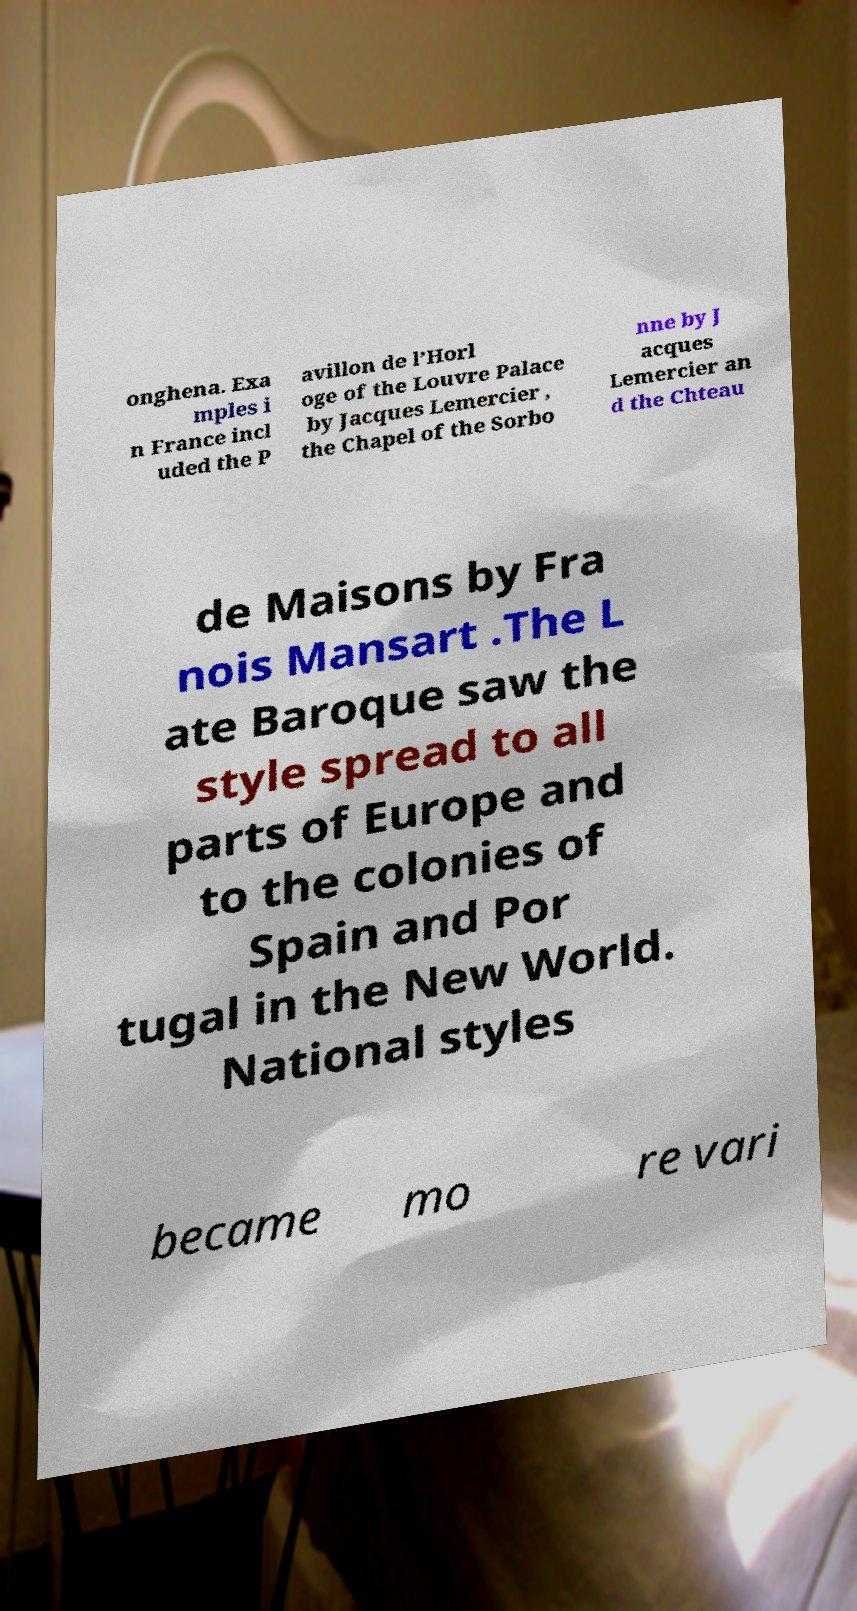There's text embedded in this image that I need extracted. Can you transcribe it verbatim? onghena. Exa mples i n France incl uded the P avillon de l’Horl oge of the Louvre Palace by Jacques Lemercier , the Chapel of the Sorbo nne by J acques Lemercier an d the Chteau de Maisons by Fra nois Mansart .The L ate Baroque saw the style spread to all parts of Europe and to the colonies of Spain and Por tugal in the New World. National styles became mo re vari 